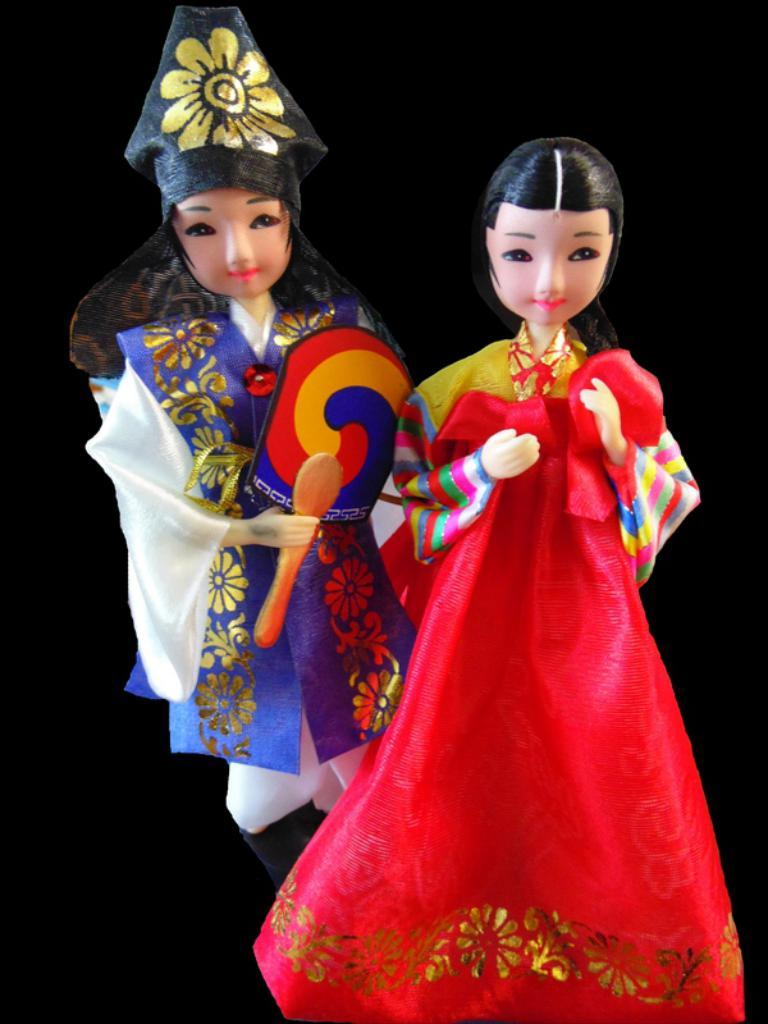How many dolls are present in the image? There are two dolls in the image. What can be seen in the background of the image? The background of the image is black. What type of desk is visible in the image? There is no desk present in the image; it only features two dolls against a black background. Can you tell me how many volleyballs are being used by the dolls in the image? There are no volleyballs present in the image; it only features two dolls against a black background. 